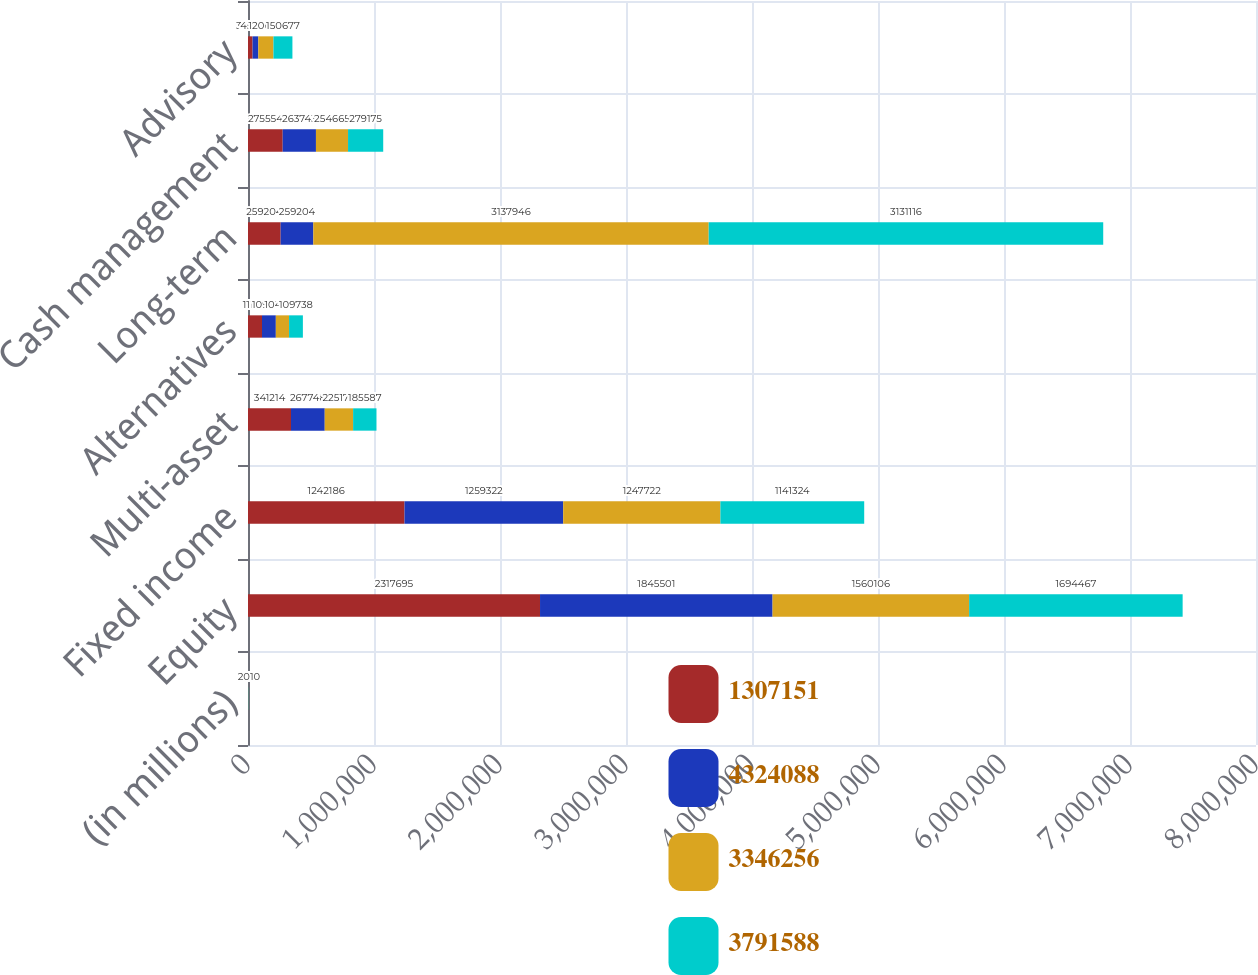Convert chart. <chart><loc_0><loc_0><loc_500><loc_500><stacked_bar_chart><ecel><fcel>(in millions)<fcel>Equity<fcel>Fixed income<fcel>Multi-asset<fcel>Alternatives<fcel>Long-term<fcel>Cash management<fcel>Advisory<nl><fcel>1.30715e+06<fcel>2013<fcel>2.3177e+06<fcel>1.24219e+06<fcel>341214<fcel>111114<fcel>259204<fcel>275554<fcel>36325<nl><fcel>4.32409e+06<fcel>2012<fcel>1.8455e+06<fcel>1.25932e+06<fcel>267748<fcel>109795<fcel>259204<fcel>263743<fcel>45479<nl><fcel>3.34626e+06<fcel>2011<fcel>1.56011e+06<fcel>1.24772e+06<fcel>225170<fcel>104948<fcel>3.13795e+06<fcel>254665<fcel>120070<nl><fcel>3.79159e+06<fcel>2010<fcel>1.69447e+06<fcel>1.14132e+06<fcel>185587<fcel>109738<fcel>3.13112e+06<fcel>279175<fcel>150677<nl></chart> 